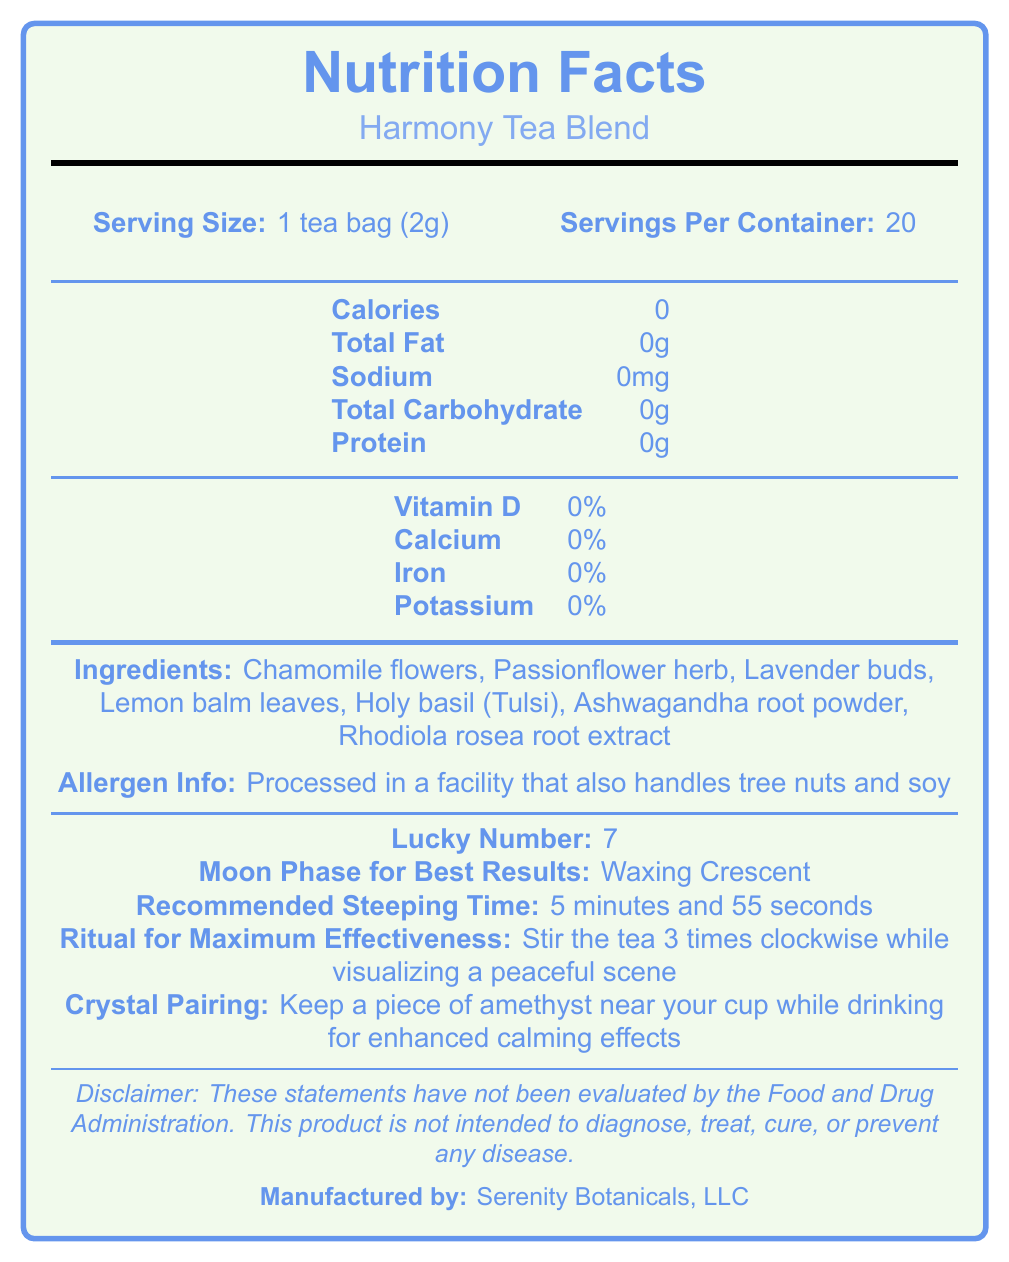What is the serving size of the Harmony Tea Blend? The serving size is explicitly mentioned as "1 tea bag (2g)" on the label.
Answer: 1 tea bag (2g) How many servings are there per container? The label indicates that there are 20 servings per container.
Answer: 20 What is the total fat content in one serving? The total fat content per serving is listed as 0g.
Answer: 0g What is the recommended steeping time for the tea? The label specifies that the recommended steeping time is 5 minutes and 55 seconds.
Answer: 5 minutes and 55 seconds What herbs and adaptogens are included in the ingredients? The ingredients list includes all these herbs and adaptogens.
Answer: Chamomile flowers, Passionflower herb, Lavender buds, Lemon balm leaves, Holy basil (Tulsi), Ashwagandha root powder, Rhodiola rosea root extract What is the recommended ritual for maximum effectiveness? The label states that for maximum effectiveness, you should stir the tea 3 times clockwise while visualizing a peaceful scene.
Answer: Stir the tea 3 times clockwise while visualizing a peaceful scene Who is the manufacturer of the Harmony Tea Blend? The label mentions that the manufacturer is Serenity Botanicals, LLC.
Answer: Serenity Botanicals, LLC What is the crystal pairing suggested for enhanced calming effects? The label suggests keeping a piece of amethyst near your cup for enhanced calming effects.
Answer: Amethyst What is the calorie content per serving? The calorie content per serving is listed as 0 on the Nutrition Facts.
Answer: 0 Which moon phase is recommended for best results? The label indicates that the Waxing Crescent moon phase is the best time for using the tea.
Answer: Waxing Crescent Where should the tea be stored for best results? A. In the fridge B. In a drawer C. In a cool, dry place away from direct sunlight D. In a warm, moist place According to the label, the tea should be stored in a cool, dry place away from direct sunlight.
Answer: C Which element is NOT listed in the Harmony Tea Blend? I. Lavender Buds II. Magnesium III. Chamomile Flowers The document does not mention Magnesium in the ingredient list.
Answer: II What is the lucky number associated with this tea blend? The label lists 7 as the lucky number.
Answer: 7 Are there any calories in Harmony Tea Blend? The label states that the calorie content is 0, indicating no calories.
Answer: No Does the Harmony Tea Blend contain any tree nuts or soy? The tea itself does not contain tree nuts or soy but is processed in a facility that handles them.
Answer: Processed in a facility that handles tree nuts and soy Summarize the main idea of the Harmony Tea Blend document. The document is centered around the Harmony Tea Blend, providing all necessary details about its nutritional content, ingredient list, preparation instructions, and additional rituals for maximizing its calming effects.
Answer: The document provides the Nutrition Facts, ingredients, and special preparation instructions for Harmony Tea Blend. It details that the tea contains zero calories, fats, carbohydrates, and proteins. It lists calming herbs and adaptogens as ingredients and recommends rituals and crystal pairing for enhanced stress relief and relaxation effects. It also includes allergen information and storage instructions. How many calories will you consume if you drink two servings of Harmony Tea Blend? Each serving contains 0 calories, so two servings would also contain 0 calories.
Answer: 0 Which vitamin or mineral is present in this tea? The label indicates that there is no Vitamin D, Calcium, Iron, or Potassium.
Answer: None What benefits does this product claim to provide? A. Weight loss B. Digestive health C. Stress relief and balance D. Immune support The label highlights benefits such as promoting relaxation, enhancing mood, and supporting stress management which falls under stress relief and balance.
Answer: C What type of packaging does Harmony Tea Blend use? The document states that the tea bags are made from biodegradable materials and are packed in a recyclable cardboard box.
Answer: Biodegradable tea bags and recyclable cardboard box What is the ratio of total servings per container to the lucky number? (Assume the lucky number is 7) The total servings per container is 20. The lucky number is 7. The ratio is 20 / 7 ≈ 2.86.
Answer: Approximately 2.86 Does the product treat or cure any disease according to the label? The disclaimer clearly states that the product is not intended to diagnose, treat, cure, or prevent any disease.
Answer: No What is the visual theme color used in the document for the sections like lines, text, and borders? The document uses 'calmblue' for various visual elements like lines, text, and borders.
Answer: Calm blue Does the label mention any required meditation practice while consuming the tea? The label suggests visualizing a peaceful scene while stirring the tea for maximum effectiveness, which can be seen as a meditative act but is not explicitly termed meditation.
Answer: Not specifically meditation but visualizing a peaceful scene while stirring What is the iron percentage per serving in Harmony Tea Blend? The Nutrition Facts section lists Iron as 0%.
Answer: 0% What beneficial claim is NOT made about the product? A. Supports digestive health B. Promotes relaxation and calmness C. Enhances mood and emotional balance D. Aids in restful sleep Among the listed benefits, "Supports digestive health" is not mentioned. The other benefits are clearly stated in the document.
Answer: A 